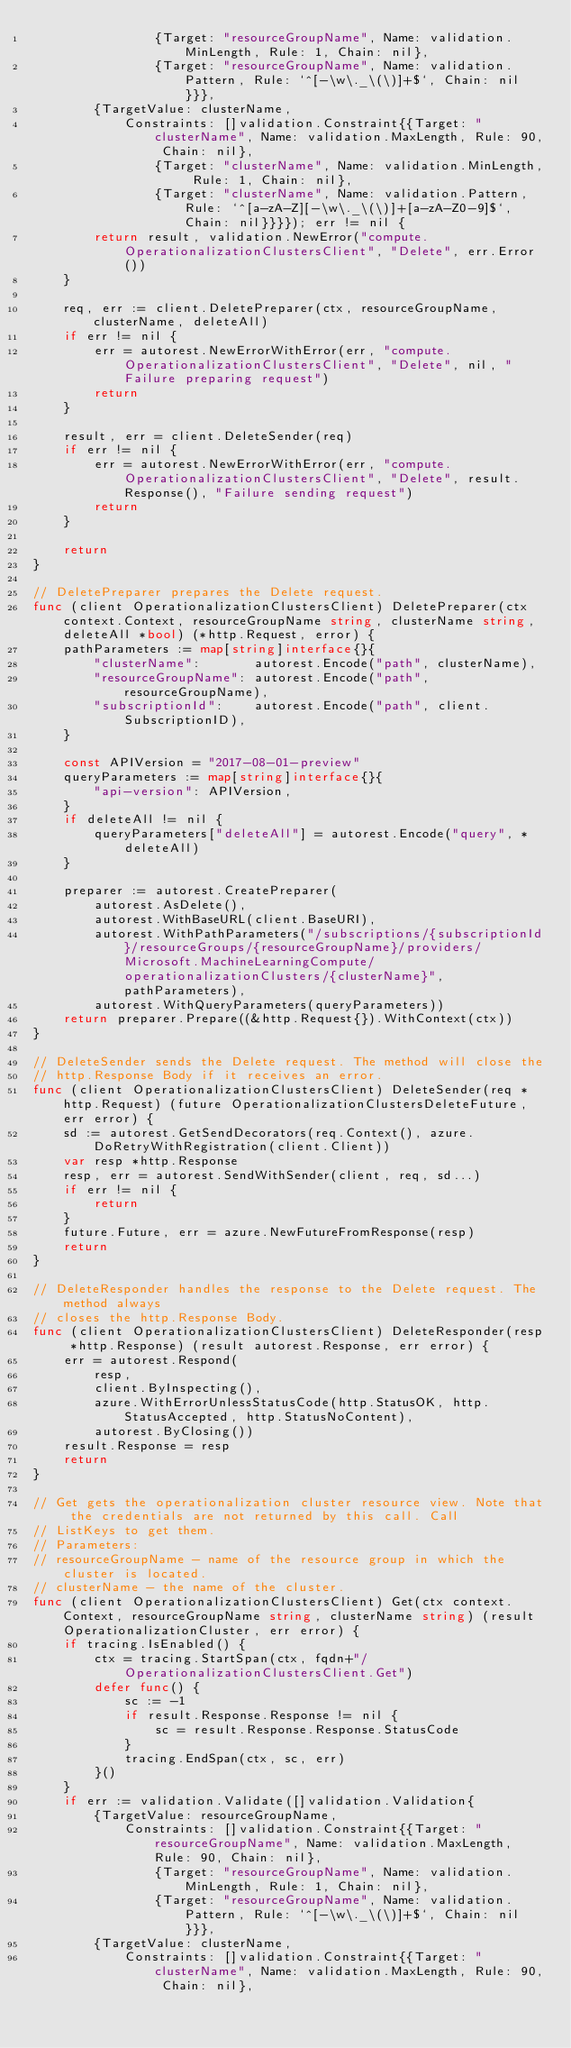Convert code to text. <code><loc_0><loc_0><loc_500><loc_500><_Go_>				{Target: "resourceGroupName", Name: validation.MinLength, Rule: 1, Chain: nil},
				{Target: "resourceGroupName", Name: validation.Pattern, Rule: `^[-\w\._\(\)]+$`, Chain: nil}}},
		{TargetValue: clusterName,
			Constraints: []validation.Constraint{{Target: "clusterName", Name: validation.MaxLength, Rule: 90, Chain: nil},
				{Target: "clusterName", Name: validation.MinLength, Rule: 1, Chain: nil},
				{Target: "clusterName", Name: validation.Pattern, Rule: `^[a-zA-Z][-\w\._\(\)]+[a-zA-Z0-9]$`, Chain: nil}}}}); err != nil {
		return result, validation.NewError("compute.OperationalizationClustersClient", "Delete", err.Error())
	}

	req, err := client.DeletePreparer(ctx, resourceGroupName, clusterName, deleteAll)
	if err != nil {
		err = autorest.NewErrorWithError(err, "compute.OperationalizationClustersClient", "Delete", nil, "Failure preparing request")
		return
	}

	result, err = client.DeleteSender(req)
	if err != nil {
		err = autorest.NewErrorWithError(err, "compute.OperationalizationClustersClient", "Delete", result.Response(), "Failure sending request")
		return
	}

	return
}

// DeletePreparer prepares the Delete request.
func (client OperationalizationClustersClient) DeletePreparer(ctx context.Context, resourceGroupName string, clusterName string, deleteAll *bool) (*http.Request, error) {
	pathParameters := map[string]interface{}{
		"clusterName":       autorest.Encode("path", clusterName),
		"resourceGroupName": autorest.Encode("path", resourceGroupName),
		"subscriptionId":    autorest.Encode("path", client.SubscriptionID),
	}

	const APIVersion = "2017-08-01-preview"
	queryParameters := map[string]interface{}{
		"api-version": APIVersion,
	}
	if deleteAll != nil {
		queryParameters["deleteAll"] = autorest.Encode("query", *deleteAll)
	}

	preparer := autorest.CreatePreparer(
		autorest.AsDelete(),
		autorest.WithBaseURL(client.BaseURI),
		autorest.WithPathParameters("/subscriptions/{subscriptionId}/resourceGroups/{resourceGroupName}/providers/Microsoft.MachineLearningCompute/operationalizationClusters/{clusterName}", pathParameters),
		autorest.WithQueryParameters(queryParameters))
	return preparer.Prepare((&http.Request{}).WithContext(ctx))
}

// DeleteSender sends the Delete request. The method will close the
// http.Response Body if it receives an error.
func (client OperationalizationClustersClient) DeleteSender(req *http.Request) (future OperationalizationClustersDeleteFuture, err error) {
	sd := autorest.GetSendDecorators(req.Context(), azure.DoRetryWithRegistration(client.Client))
	var resp *http.Response
	resp, err = autorest.SendWithSender(client, req, sd...)
	if err != nil {
		return
	}
	future.Future, err = azure.NewFutureFromResponse(resp)
	return
}

// DeleteResponder handles the response to the Delete request. The method always
// closes the http.Response Body.
func (client OperationalizationClustersClient) DeleteResponder(resp *http.Response) (result autorest.Response, err error) {
	err = autorest.Respond(
		resp,
		client.ByInspecting(),
		azure.WithErrorUnlessStatusCode(http.StatusOK, http.StatusAccepted, http.StatusNoContent),
		autorest.ByClosing())
	result.Response = resp
	return
}

// Get gets the operationalization cluster resource view. Note that the credentials are not returned by this call. Call
// ListKeys to get them.
// Parameters:
// resourceGroupName - name of the resource group in which the cluster is located.
// clusterName - the name of the cluster.
func (client OperationalizationClustersClient) Get(ctx context.Context, resourceGroupName string, clusterName string) (result OperationalizationCluster, err error) {
	if tracing.IsEnabled() {
		ctx = tracing.StartSpan(ctx, fqdn+"/OperationalizationClustersClient.Get")
		defer func() {
			sc := -1
			if result.Response.Response != nil {
				sc = result.Response.Response.StatusCode
			}
			tracing.EndSpan(ctx, sc, err)
		}()
	}
	if err := validation.Validate([]validation.Validation{
		{TargetValue: resourceGroupName,
			Constraints: []validation.Constraint{{Target: "resourceGroupName", Name: validation.MaxLength, Rule: 90, Chain: nil},
				{Target: "resourceGroupName", Name: validation.MinLength, Rule: 1, Chain: nil},
				{Target: "resourceGroupName", Name: validation.Pattern, Rule: `^[-\w\._\(\)]+$`, Chain: nil}}},
		{TargetValue: clusterName,
			Constraints: []validation.Constraint{{Target: "clusterName", Name: validation.MaxLength, Rule: 90, Chain: nil},</code> 